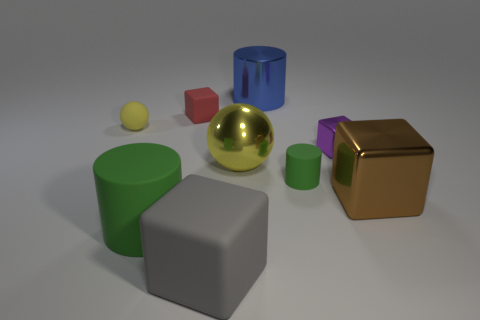Add 1 yellow matte cylinders. How many objects exist? 10 Subtract all blocks. How many objects are left? 5 Subtract all large red metallic spheres. Subtract all matte cylinders. How many objects are left? 7 Add 3 big spheres. How many big spheres are left? 4 Add 2 blue cylinders. How many blue cylinders exist? 3 Subtract 0 green cubes. How many objects are left? 9 